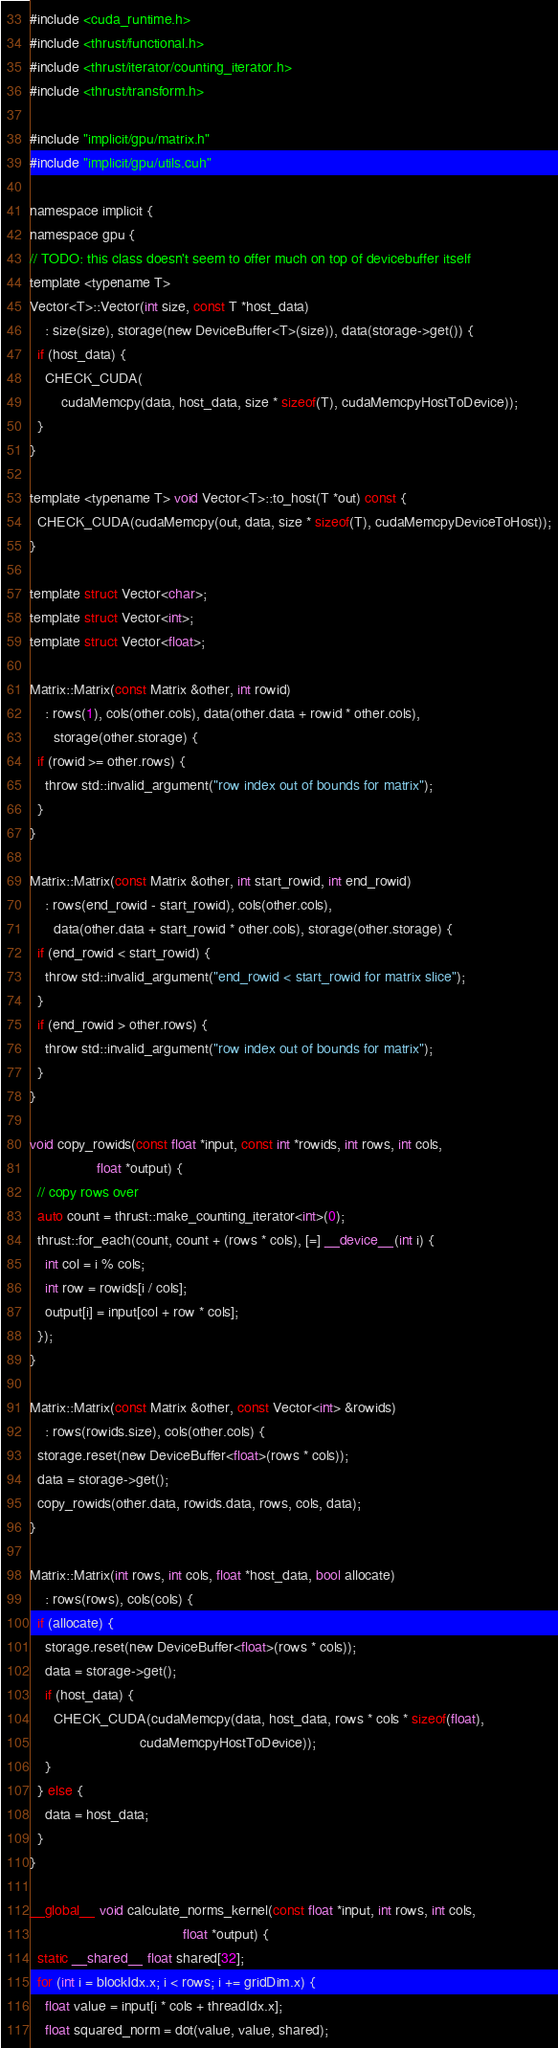Convert code to text. <code><loc_0><loc_0><loc_500><loc_500><_Cuda_>#include <cuda_runtime.h>
#include <thrust/functional.h>
#include <thrust/iterator/counting_iterator.h>
#include <thrust/transform.h>

#include "implicit/gpu/matrix.h"
#include "implicit/gpu/utils.cuh"

namespace implicit {
namespace gpu {
// TODO: this class doesn't seem to offer much on top of devicebuffer itself
template <typename T>
Vector<T>::Vector(int size, const T *host_data)
    : size(size), storage(new DeviceBuffer<T>(size)), data(storage->get()) {
  if (host_data) {
    CHECK_CUDA(
        cudaMemcpy(data, host_data, size * sizeof(T), cudaMemcpyHostToDevice));
  }
}

template <typename T> void Vector<T>::to_host(T *out) const {
  CHECK_CUDA(cudaMemcpy(out, data, size * sizeof(T), cudaMemcpyDeviceToHost));
}

template struct Vector<char>;
template struct Vector<int>;
template struct Vector<float>;

Matrix::Matrix(const Matrix &other, int rowid)
    : rows(1), cols(other.cols), data(other.data + rowid * other.cols),
      storage(other.storage) {
  if (rowid >= other.rows) {
    throw std::invalid_argument("row index out of bounds for matrix");
  }
}

Matrix::Matrix(const Matrix &other, int start_rowid, int end_rowid)
    : rows(end_rowid - start_rowid), cols(other.cols),
      data(other.data + start_rowid * other.cols), storage(other.storage) {
  if (end_rowid < start_rowid) {
    throw std::invalid_argument("end_rowid < start_rowid for matrix slice");
  }
  if (end_rowid > other.rows) {
    throw std::invalid_argument("row index out of bounds for matrix");
  }
}

void copy_rowids(const float *input, const int *rowids, int rows, int cols,
                 float *output) {
  // copy rows over
  auto count = thrust::make_counting_iterator<int>(0);
  thrust::for_each(count, count + (rows * cols), [=] __device__(int i) {
    int col = i % cols;
    int row = rowids[i / cols];
    output[i] = input[col + row * cols];
  });
}

Matrix::Matrix(const Matrix &other, const Vector<int> &rowids)
    : rows(rowids.size), cols(other.cols) {
  storage.reset(new DeviceBuffer<float>(rows * cols));
  data = storage->get();
  copy_rowids(other.data, rowids.data, rows, cols, data);
}

Matrix::Matrix(int rows, int cols, float *host_data, bool allocate)
    : rows(rows), cols(cols) {
  if (allocate) {
    storage.reset(new DeviceBuffer<float>(rows * cols));
    data = storage->get();
    if (host_data) {
      CHECK_CUDA(cudaMemcpy(data, host_data, rows * cols * sizeof(float),
                            cudaMemcpyHostToDevice));
    }
  } else {
    data = host_data;
  }
}

__global__ void calculate_norms_kernel(const float *input, int rows, int cols,
                                       float *output) {
  static __shared__ float shared[32];
  for (int i = blockIdx.x; i < rows; i += gridDim.x) {
    float value = input[i * cols + threadIdx.x];
    float squared_norm = dot(value, value, shared);</code> 